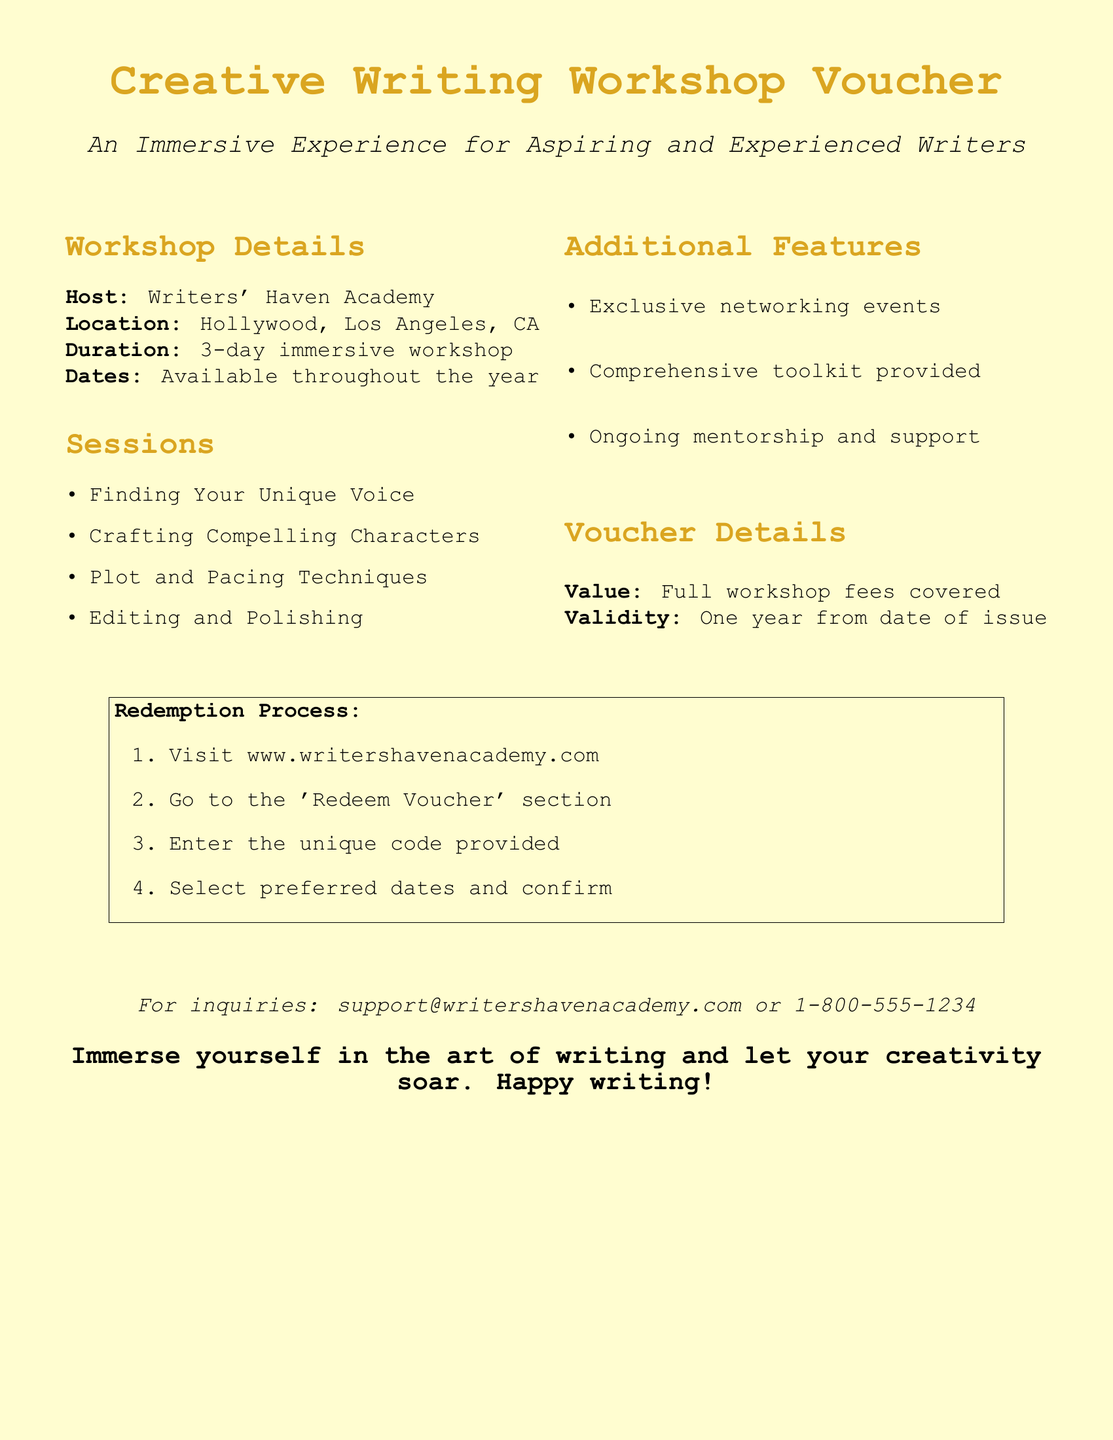What is the host of the workshop? The host of the workshop is indicated in the document under the workshop details section.
Answer: Writers' Haven Academy Where is the workshop located? The location is provided in the workshop details section of the document.
Answer: Hollywood, Los Angeles, CA What is the duration of the workshop? The duration is specified in the workshop details section, indicating how long the workshop will last.
Answer: 3-day immersive workshop What are the available dates for the workshop? The document notes the dates related to workshop availability, which is mentioned in the workshop details.
Answer: Available throughout the year What workshop session focuses on character development? The specific session for character development can be found in the list of sessions provided.
Answer: Crafting Compelling Characters What value does the voucher cover? The document specifies what the voucher value includes under voucher details.
Answer: Full workshop fees covered How long is the voucher valid? The validity period is stated clearly in the voucher details section of the document.
Answer: One year from date of issue What is the first step in the redemption process? The redemption process outlines specific steps, and the first step is listed in the document.
Answer: Visit www.writershavenacademy.com What support is offered after the workshop? This information can be found in the additional features section of the document.
Answer: Ongoing mentorship and support 